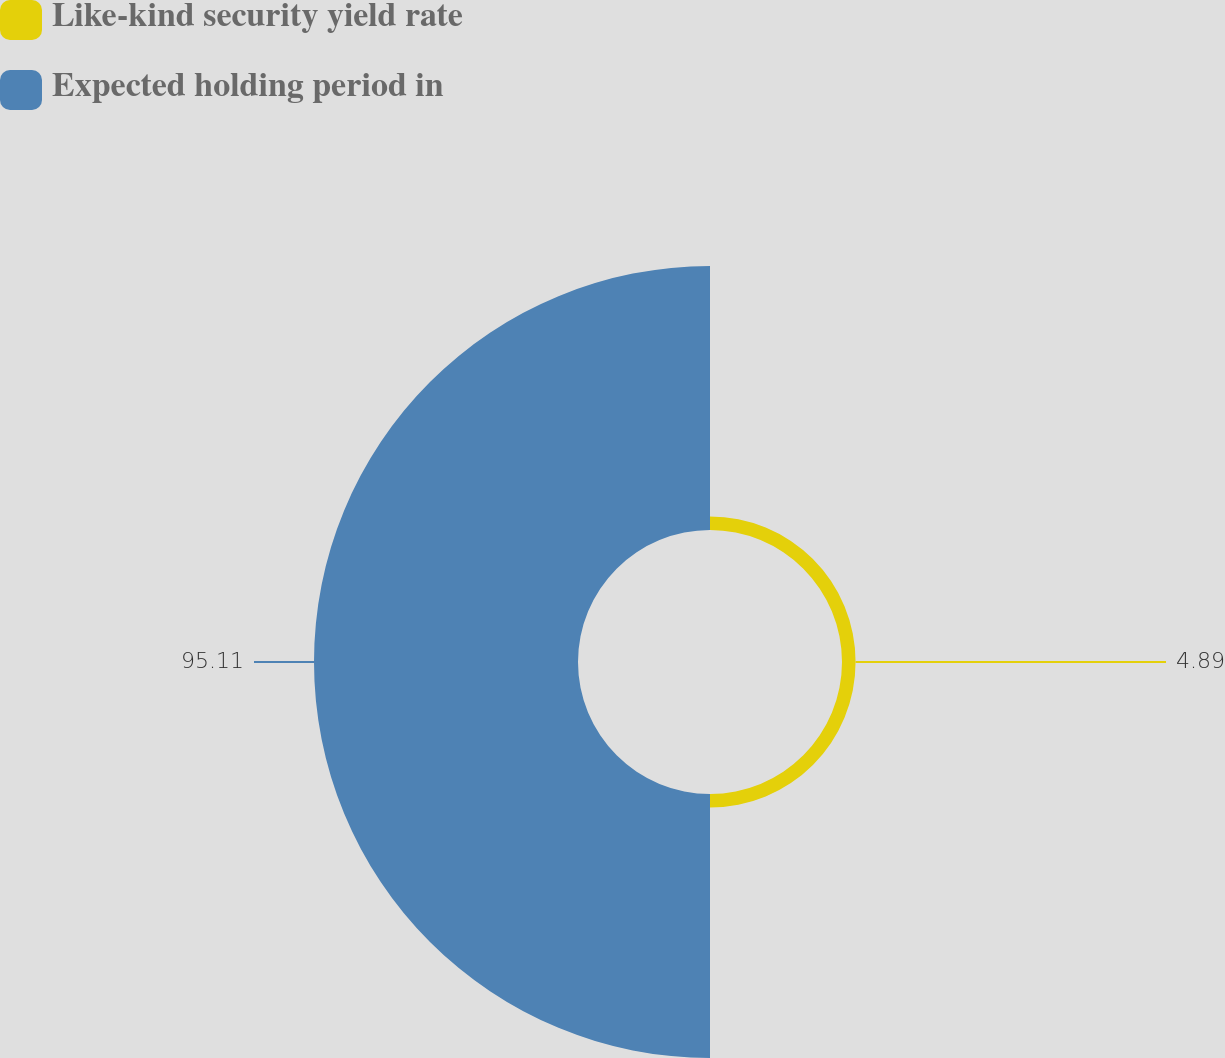Convert chart to OTSL. <chart><loc_0><loc_0><loc_500><loc_500><pie_chart><fcel>Like-kind security yield rate<fcel>Expected holding period in<nl><fcel>4.89%<fcel>95.11%<nl></chart> 